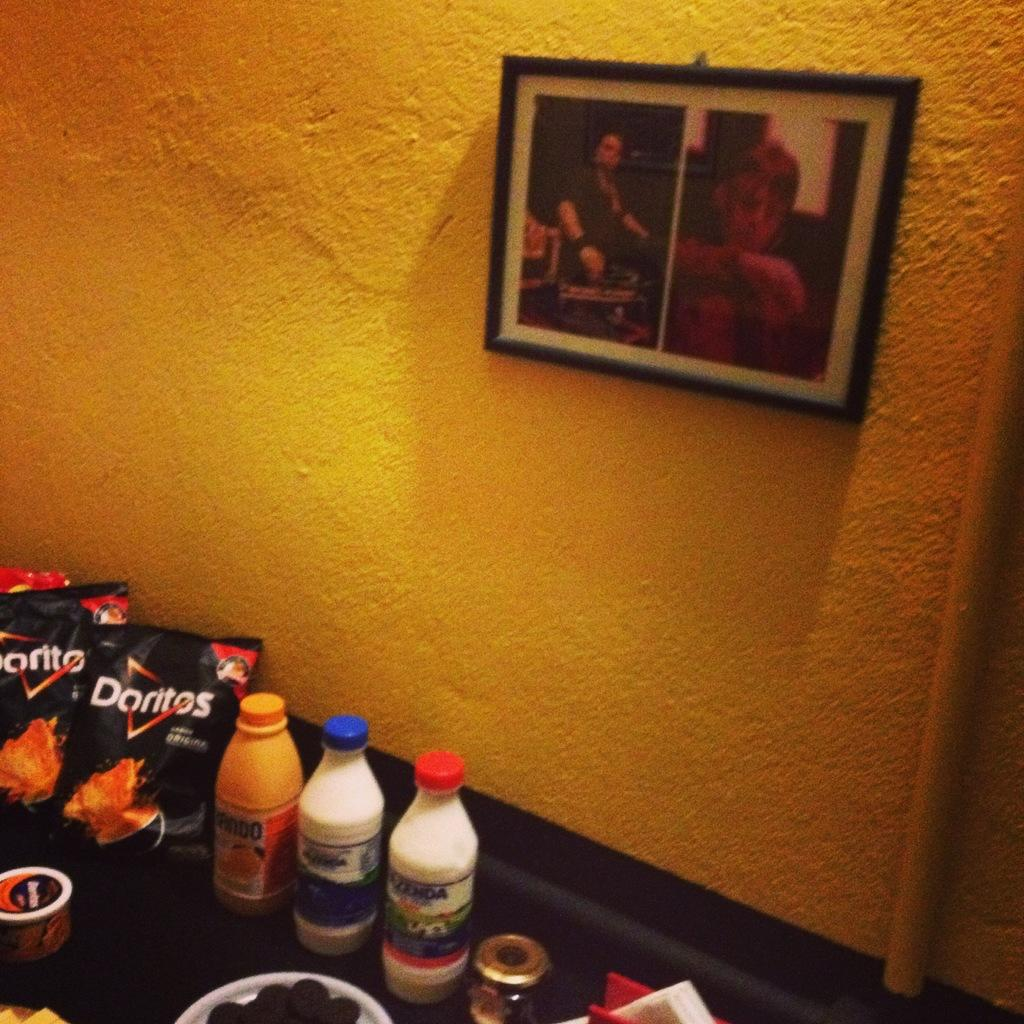<image>
Summarize the visual content of the image. Two bags of Doritos next to three bottles 